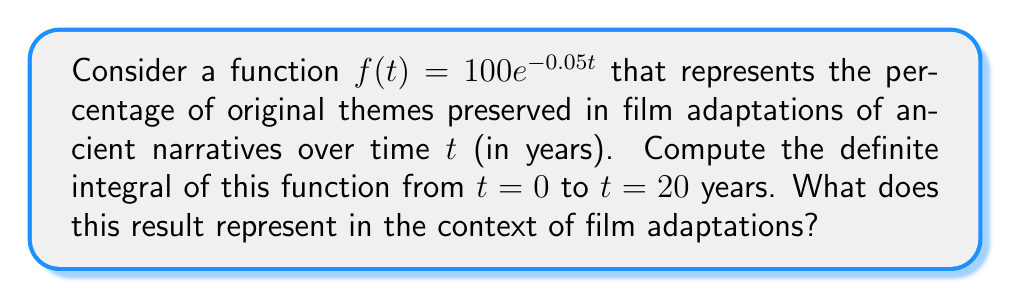Can you solve this math problem? To solve this problem, we need to integrate the given function $f(t) = 100e^{-0.05t}$ from $t=0$ to $t=20$. Let's break it down step by step:

1) The indefinite integral of $e^{kx}$ is $\frac{1}{k}e^{kx} + C$. In our case, $k = -0.05$.

2) Therefore, the indefinite integral of $f(t)$ is:

   $$\int 100e^{-0.05t} dt = -2000e^{-0.05t} + C$$

3) Now, we need to evaluate this at the given limits:

   $$\int_0^{20} 100e^{-0.05t} dt = [-2000e^{-0.05t}]_0^{20}$$

4) Let's evaluate this:

   $$= -2000e^{-0.05(20)} - (-2000e^{-0.05(0)})$$
   $$= -2000e^{-1} - (-2000)$$
   $$= -2000 \cdot 0.3679 + 2000$$
   $$= -735.8 + 2000$$
   $$= 1264.2$$

5) In the context of film adaptations, this result represents the total area under the curve from 0 to 20 years, which can be interpreted as the cumulative preservation of original themes over this time period.

6) The units of this result would be percentage-years, representing a combination of the percentage of themes preserved and the time over which they were preserved.
Answer: The definite integral of $f(t) = 100e^{-0.05t}$ from $t=0$ to $t=20$ is approximately 1264.2 percentage-years. This represents the cumulative preservation of original themes in film adaptations of ancient narratives over a 20-year period. 